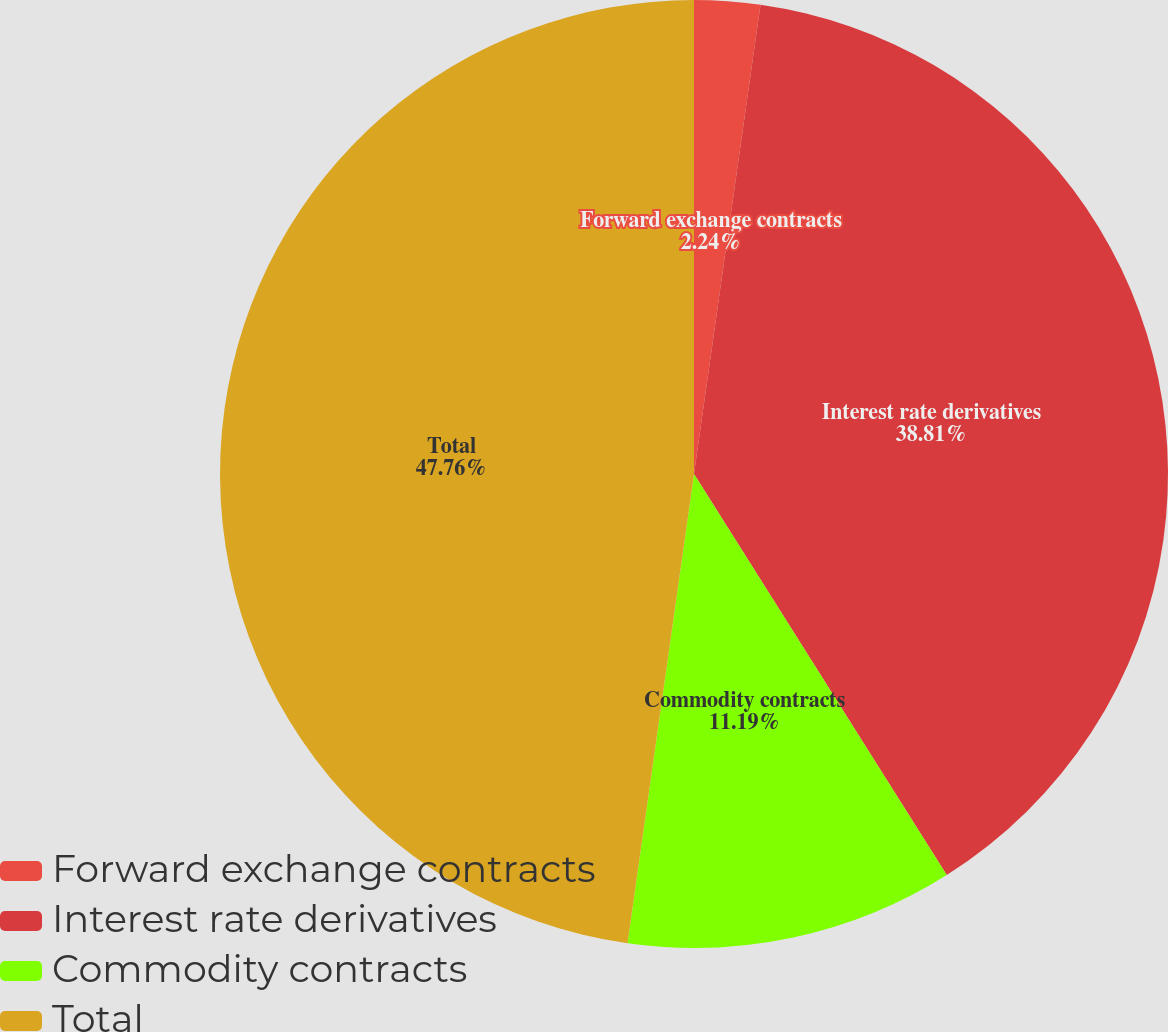Convert chart. <chart><loc_0><loc_0><loc_500><loc_500><pie_chart><fcel>Forward exchange contracts<fcel>Interest rate derivatives<fcel>Commodity contracts<fcel>Total<nl><fcel>2.24%<fcel>38.81%<fcel>11.19%<fcel>47.76%<nl></chart> 